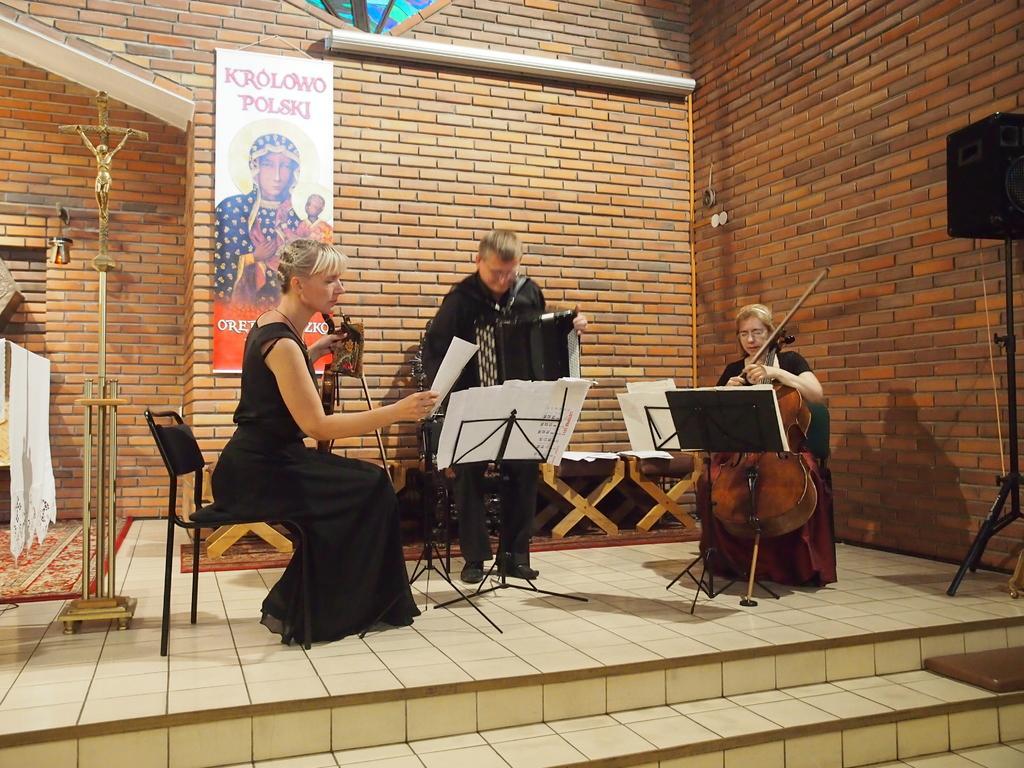Could you give a brief overview of what you see in this image? In the middle of the image few people are sitting and holding some musical instruments in their hands and there are some chairs. Behind them there is a wall on the wall there is a banner. Top right side of the image there is a speaker. Bottom of the image there are some steps. 